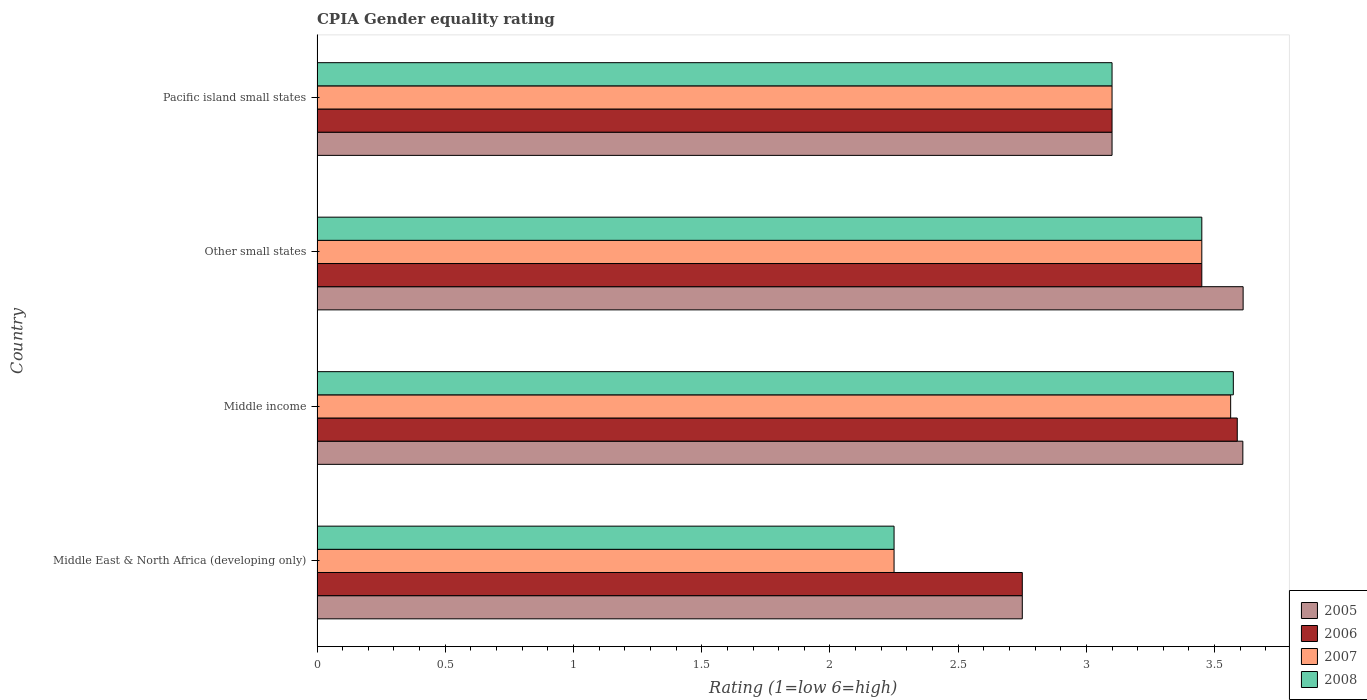How many different coloured bars are there?
Offer a terse response. 4. How many groups of bars are there?
Give a very brief answer. 4. What is the label of the 2nd group of bars from the top?
Ensure brevity in your answer.  Other small states. In how many cases, is the number of bars for a given country not equal to the number of legend labels?
Provide a succinct answer. 0. What is the CPIA rating in 2006 in Other small states?
Your answer should be very brief. 3.45. Across all countries, what is the maximum CPIA rating in 2006?
Make the answer very short. 3.59. Across all countries, what is the minimum CPIA rating in 2006?
Offer a very short reply. 2.75. In which country was the CPIA rating in 2006 maximum?
Provide a short and direct response. Middle income. In which country was the CPIA rating in 2007 minimum?
Make the answer very short. Middle East & North Africa (developing only). What is the total CPIA rating in 2005 in the graph?
Your response must be concise. 13.07. What is the difference between the CPIA rating in 2007 in Middle income and that in Pacific island small states?
Ensure brevity in your answer.  0.46. What is the difference between the CPIA rating in 2006 in Pacific island small states and the CPIA rating in 2005 in Other small states?
Offer a very short reply. -0.51. What is the average CPIA rating in 2008 per country?
Make the answer very short. 3.09. What is the difference between the CPIA rating in 2007 and CPIA rating in 2008 in Pacific island small states?
Your answer should be compact. 0. What is the ratio of the CPIA rating in 2006 in Middle East & North Africa (developing only) to that in Pacific island small states?
Your response must be concise. 0.89. What is the difference between the highest and the second highest CPIA rating in 2007?
Provide a succinct answer. 0.11. What is the difference between the highest and the lowest CPIA rating in 2005?
Your answer should be very brief. 0.86. In how many countries, is the CPIA rating in 2008 greater than the average CPIA rating in 2008 taken over all countries?
Ensure brevity in your answer.  3. What does the 3rd bar from the bottom in Other small states represents?
Make the answer very short. 2007. Is it the case that in every country, the sum of the CPIA rating in 2007 and CPIA rating in 2006 is greater than the CPIA rating in 2008?
Make the answer very short. Yes. Are all the bars in the graph horizontal?
Ensure brevity in your answer.  Yes. Does the graph contain any zero values?
Provide a succinct answer. No. Does the graph contain grids?
Your answer should be very brief. No. Where does the legend appear in the graph?
Make the answer very short. Bottom right. How are the legend labels stacked?
Make the answer very short. Vertical. What is the title of the graph?
Ensure brevity in your answer.  CPIA Gender equality rating. Does "1976" appear as one of the legend labels in the graph?
Ensure brevity in your answer.  No. What is the label or title of the X-axis?
Give a very brief answer. Rating (1=low 6=high). What is the label or title of the Y-axis?
Keep it short and to the point. Country. What is the Rating (1=low 6=high) in 2005 in Middle East & North Africa (developing only)?
Offer a very short reply. 2.75. What is the Rating (1=low 6=high) in 2006 in Middle East & North Africa (developing only)?
Provide a succinct answer. 2.75. What is the Rating (1=low 6=high) in 2007 in Middle East & North Africa (developing only)?
Offer a terse response. 2.25. What is the Rating (1=low 6=high) of 2008 in Middle East & North Africa (developing only)?
Make the answer very short. 2.25. What is the Rating (1=low 6=high) in 2005 in Middle income?
Provide a succinct answer. 3.61. What is the Rating (1=low 6=high) of 2006 in Middle income?
Offer a very short reply. 3.59. What is the Rating (1=low 6=high) of 2007 in Middle income?
Your answer should be very brief. 3.56. What is the Rating (1=low 6=high) of 2008 in Middle income?
Ensure brevity in your answer.  3.57. What is the Rating (1=low 6=high) in 2005 in Other small states?
Give a very brief answer. 3.61. What is the Rating (1=low 6=high) in 2006 in Other small states?
Ensure brevity in your answer.  3.45. What is the Rating (1=low 6=high) in 2007 in Other small states?
Provide a succinct answer. 3.45. What is the Rating (1=low 6=high) of 2008 in Other small states?
Give a very brief answer. 3.45. What is the Rating (1=low 6=high) in 2006 in Pacific island small states?
Offer a very short reply. 3.1. What is the Rating (1=low 6=high) of 2007 in Pacific island small states?
Make the answer very short. 3.1. What is the Rating (1=low 6=high) of 2008 in Pacific island small states?
Offer a very short reply. 3.1. Across all countries, what is the maximum Rating (1=low 6=high) in 2005?
Give a very brief answer. 3.61. Across all countries, what is the maximum Rating (1=low 6=high) in 2006?
Provide a succinct answer. 3.59. Across all countries, what is the maximum Rating (1=low 6=high) in 2007?
Offer a very short reply. 3.56. Across all countries, what is the maximum Rating (1=low 6=high) in 2008?
Your response must be concise. 3.57. Across all countries, what is the minimum Rating (1=low 6=high) of 2005?
Your answer should be compact. 2.75. Across all countries, what is the minimum Rating (1=low 6=high) of 2006?
Your answer should be compact. 2.75. Across all countries, what is the minimum Rating (1=low 6=high) in 2007?
Offer a terse response. 2.25. Across all countries, what is the minimum Rating (1=low 6=high) in 2008?
Make the answer very short. 2.25. What is the total Rating (1=low 6=high) of 2005 in the graph?
Offer a very short reply. 13.07. What is the total Rating (1=low 6=high) of 2006 in the graph?
Offer a very short reply. 12.89. What is the total Rating (1=low 6=high) in 2007 in the graph?
Your answer should be very brief. 12.36. What is the total Rating (1=low 6=high) in 2008 in the graph?
Your response must be concise. 12.37. What is the difference between the Rating (1=low 6=high) in 2005 in Middle East & North Africa (developing only) and that in Middle income?
Your answer should be compact. -0.86. What is the difference between the Rating (1=low 6=high) in 2006 in Middle East & North Africa (developing only) and that in Middle income?
Make the answer very short. -0.84. What is the difference between the Rating (1=low 6=high) of 2007 in Middle East & North Africa (developing only) and that in Middle income?
Provide a short and direct response. -1.31. What is the difference between the Rating (1=low 6=high) of 2008 in Middle East & North Africa (developing only) and that in Middle income?
Offer a terse response. -1.32. What is the difference between the Rating (1=low 6=high) in 2005 in Middle East & North Africa (developing only) and that in Other small states?
Provide a succinct answer. -0.86. What is the difference between the Rating (1=low 6=high) in 2006 in Middle East & North Africa (developing only) and that in Other small states?
Provide a succinct answer. -0.7. What is the difference between the Rating (1=low 6=high) in 2008 in Middle East & North Africa (developing only) and that in Other small states?
Offer a very short reply. -1.2. What is the difference between the Rating (1=low 6=high) in 2005 in Middle East & North Africa (developing only) and that in Pacific island small states?
Give a very brief answer. -0.35. What is the difference between the Rating (1=low 6=high) of 2006 in Middle East & North Africa (developing only) and that in Pacific island small states?
Make the answer very short. -0.35. What is the difference between the Rating (1=low 6=high) of 2007 in Middle East & North Africa (developing only) and that in Pacific island small states?
Make the answer very short. -0.85. What is the difference between the Rating (1=low 6=high) in 2008 in Middle East & North Africa (developing only) and that in Pacific island small states?
Your answer should be very brief. -0.85. What is the difference between the Rating (1=low 6=high) in 2005 in Middle income and that in Other small states?
Offer a very short reply. -0. What is the difference between the Rating (1=low 6=high) in 2006 in Middle income and that in Other small states?
Make the answer very short. 0.14. What is the difference between the Rating (1=low 6=high) in 2007 in Middle income and that in Other small states?
Your answer should be compact. 0.11. What is the difference between the Rating (1=low 6=high) of 2008 in Middle income and that in Other small states?
Offer a terse response. 0.12. What is the difference between the Rating (1=low 6=high) in 2005 in Middle income and that in Pacific island small states?
Offer a very short reply. 0.51. What is the difference between the Rating (1=low 6=high) of 2006 in Middle income and that in Pacific island small states?
Ensure brevity in your answer.  0.49. What is the difference between the Rating (1=low 6=high) of 2007 in Middle income and that in Pacific island small states?
Provide a short and direct response. 0.46. What is the difference between the Rating (1=low 6=high) of 2008 in Middle income and that in Pacific island small states?
Provide a succinct answer. 0.47. What is the difference between the Rating (1=low 6=high) in 2005 in Other small states and that in Pacific island small states?
Your answer should be very brief. 0.51. What is the difference between the Rating (1=low 6=high) of 2006 in Other small states and that in Pacific island small states?
Keep it short and to the point. 0.35. What is the difference between the Rating (1=low 6=high) of 2007 in Other small states and that in Pacific island small states?
Your answer should be compact. 0.35. What is the difference between the Rating (1=low 6=high) of 2008 in Other small states and that in Pacific island small states?
Make the answer very short. 0.35. What is the difference between the Rating (1=low 6=high) in 2005 in Middle East & North Africa (developing only) and the Rating (1=low 6=high) in 2006 in Middle income?
Keep it short and to the point. -0.84. What is the difference between the Rating (1=low 6=high) of 2005 in Middle East & North Africa (developing only) and the Rating (1=low 6=high) of 2007 in Middle income?
Provide a succinct answer. -0.81. What is the difference between the Rating (1=low 6=high) in 2005 in Middle East & North Africa (developing only) and the Rating (1=low 6=high) in 2008 in Middle income?
Offer a terse response. -0.82. What is the difference between the Rating (1=low 6=high) in 2006 in Middle East & North Africa (developing only) and the Rating (1=low 6=high) in 2007 in Middle income?
Give a very brief answer. -0.81. What is the difference between the Rating (1=low 6=high) in 2006 in Middle East & North Africa (developing only) and the Rating (1=low 6=high) in 2008 in Middle income?
Make the answer very short. -0.82. What is the difference between the Rating (1=low 6=high) of 2007 in Middle East & North Africa (developing only) and the Rating (1=low 6=high) of 2008 in Middle income?
Your response must be concise. -1.32. What is the difference between the Rating (1=low 6=high) of 2005 in Middle East & North Africa (developing only) and the Rating (1=low 6=high) of 2006 in Other small states?
Keep it short and to the point. -0.7. What is the difference between the Rating (1=low 6=high) of 2005 in Middle East & North Africa (developing only) and the Rating (1=low 6=high) of 2008 in Other small states?
Offer a very short reply. -0.7. What is the difference between the Rating (1=low 6=high) in 2006 in Middle East & North Africa (developing only) and the Rating (1=low 6=high) in 2007 in Other small states?
Your answer should be very brief. -0.7. What is the difference between the Rating (1=low 6=high) in 2006 in Middle East & North Africa (developing only) and the Rating (1=low 6=high) in 2008 in Other small states?
Your response must be concise. -0.7. What is the difference between the Rating (1=low 6=high) in 2005 in Middle East & North Africa (developing only) and the Rating (1=low 6=high) in 2006 in Pacific island small states?
Give a very brief answer. -0.35. What is the difference between the Rating (1=low 6=high) in 2005 in Middle East & North Africa (developing only) and the Rating (1=low 6=high) in 2007 in Pacific island small states?
Provide a short and direct response. -0.35. What is the difference between the Rating (1=low 6=high) of 2005 in Middle East & North Africa (developing only) and the Rating (1=low 6=high) of 2008 in Pacific island small states?
Ensure brevity in your answer.  -0.35. What is the difference between the Rating (1=low 6=high) of 2006 in Middle East & North Africa (developing only) and the Rating (1=low 6=high) of 2007 in Pacific island small states?
Offer a terse response. -0.35. What is the difference between the Rating (1=low 6=high) in 2006 in Middle East & North Africa (developing only) and the Rating (1=low 6=high) in 2008 in Pacific island small states?
Make the answer very short. -0.35. What is the difference between the Rating (1=low 6=high) of 2007 in Middle East & North Africa (developing only) and the Rating (1=low 6=high) of 2008 in Pacific island small states?
Keep it short and to the point. -0.85. What is the difference between the Rating (1=low 6=high) of 2005 in Middle income and the Rating (1=low 6=high) of 2006 in Other small states?
Give a very brief answer. 0.16. What is the difference between the Rating (1=low 6=high) of 2005 in Middle income and the Rating (1=low 6=high) of 2007 in Other small states?
Make the answer very short. 0.16. What is the difference between the Rating (1=low 6=high) in 2005 in Middle income and the Rating (1=low 6=high) in 2008 in Other small states?
Ensure brevity in your answer.  0.16. What is the difference between the Rating (1=low 6=high) in 2006 in Middle income and the Rating (1=low 6=high) in 2007 in Other small states?
Ensure brevity in your answer.  0.14. What is the difference between the Rating (1=low 6=high) in 2006 in Middle income and the Rating (1=low 6=high) in 2008 in Other small states?
Your response must be concise. 0.14. What is the difference between the Rating (1=low 6=high) of 2007 in Middle income and the Rating (1=low 6=high) of 2008 in Other small states?
Your answer should be compact. 0.11. What is the difference between the Rating (1=low 6=high) in 2005 in Middle income and the Rating (1=low 6=high) in 2006 in Pacific island small states?
Your response must be concise. 0.51. What is the difference between the Rating (1=low 6=high) in 2005 in Middle income and the Rating (1=low 6=high) in 2007 in Pacific island small states?
Offer a very short reply. 0.51. What is the difference between the Rating (1=low 6=high) of 2005 in Middle income and the Rating (1=low 6=high) of 2008 in Pacific island small states?
Keep it short and to the point. 0.51. What is the difference between the Rating (1=low 6=high) in 2006 in Middle income and the Rating (1=low 6=high) in 2007 in Pacific island small states?
Your answer should be very brief. 0.49. What is the difference between the Rating (1=low 6=high) of 2006 in Middle income and the Rating (1=low 6=high) of 2008 in Pacific island small states?
Your answer should be very brief. 0.49. What is the difference between the Rating (1=low 6=high) of 2007 in Middle income and the Rating (1=low 6=high) of 2008 in Pacific island small states?
Ensure brevity in your answer.  0.46. What is the difference between the Rating (1=low 6=high) of 2005 in Other small states and the Rating (1=low 6=high) of 2006 in Pacific island small states?
Make the answer very short. 0.51. What is the difference between the Rating (1=low 6=high) of 2005 in Other small states and the Rating (1=low 6=high) of 2007 in Pacific island small states?
Provide a succinct answer. 0.51. What is the difference between the Rating (1=low 6=high) in 2005 in Other small states and the Rating (1=low 6=high) in 2008 in Pacific island small states?
Keep it short and to the point. 0.51. What is the difference between the Rating (1=low 6=high) in 2007 in Other small states and the Rating (1=low 6=high) in 2008 in Pacific island small states?
Ensure brevity in your answer.  0.35. What is the average Rating (1=low 6=high) in 2005 per country?
Offer a very short reply. 3.27. What is the average Rating (1=low 6=high) of 2006 per country?
Keep it short and to the point. 3.22. What is the average Rating (1=low 6=high) of 2007 per country?
Make the answer very short. 3.09. What is the average Rating (1=low 6=high) in 2008 per country?
Offer a very short reply. 3.09. What is the difference between the Rating (1=low 6=high) in 2005 and Rating (1=low 6=high) in 2008 in Middle East & North Africa (developing only)?
Give a very brief answer. 0.5. What is the difference between the Rating (1=low 6=high) of 2005 and Rating (1=low 6=high) of 2006 in Middle income?
Offer a very short reply. 0.02. What is the difference between the Rating (1=low 6=high) in 2005 and Rating (1=low 6=high) in 2007 in Middle income?
Your answer should be very brief. 0.05. What is the difference between the Rating (1=low 6=high) in 2005 and Rating (1=low 6=high) in 2008 in Middle income?
Your answer should be very brief. 0.04. What is the difference between the Rating (1=low 6=high) of 2006 and Rating (1=low 6=high) of 2007 in Middle income?
Your response must be concise. 0.03. What is the difference between the Rating (1=low 6=high) of 2006 and Rating (1=low 6=high) of 2008 in Middle income?
Make the answer very short. 0.02. What is the difference between the Rating (1=low 6=high) of 2007 and Rating (1=low 6=high) of 2008 in Middle income?
Your response must be concise. -0.01. What is the difference between the Rating (1=low 6=high) of 2005 and Rating (1=low 6=high) of 2006 in Other small states?
Keep it short and to the point. 0.16. What is the difference between the Rating (1=low 6=high) in 2005 and Rating (1=low 6=high) in 2007 in Other small states?
Your answer should be compact. 0.16. What is the difference between the Rating (1=low 6=high) in 2005 and Rating (1=low 6=high) in 2008 in Other small states?
Provide a short and direct response. 0.16. What is the difference between the Rating (1=low 6=high) in 2007 and Rating (1=low 6=high) in 2008 in Other small states?
Offer a very short reply. 0. What is the difference between the Rating (1=low 6=high) in 2005 and Rating (1=low 6=high) in 2007 in Pacific island small states?
Provide a succinct answer. 0. What is the difference between the Rating (1=low 6=high) in 2005 and Rating (1=low 6=high) in 2008 in Pacific island small states?
Make the answer very short. 0. What is the ratio of the Rating (1=low 6=high) of 2005 in Middle East & North Africa (developing only) to that in Middle income?
Offer a very short reply. 0.76. What is the ratio of the Rating (1=low 6=high) of 2006 in Middle East & North Africa (developing only) to that in Middle income?
Provide a short and direct response. 0.77. What is the ratio of the Rating (1=low 6=high) in 2007 in Middle East & North Africa (developing only) to that in Middle income?
Give a very brief answer. 0.63. What is the ratio of the Rating (1=low 6=high) in 2008 in Middle East & North Africa (developing only) to that in Middle income?
Ensure brevity in your answer.  0.63. What is the ratio of the Rating (1=low 6=high) of 2005 in Middle East & North Africa (developing only) to that in Other small states?
Provide a succinct answer. 0.76. What is the ratio of the Rating (1=low 6=high) in 2006 in Middle East & North Africa (developing only) to that in Other small states?
Provide a succinct answer. 0.8. What is the ratio of the Rating (1=low 6=high) of 2007 in Middle East & North Africa (developing only) to that in Other small states?
Your response must be concise. 0.65. What is the ratio of the Rating (1=low 6=high) in 2008 in Middle East & North Africa (developing only) to that in Other small states?
Give a very brief answer. 0.65. What is the ratio of the Rating (1=low 6=high) of 2005 in Middle East & North Africa (developing only) to that in Pacific island small states?
Keep it short and to the point. 0.89. What is the ratio of the Rating (1=low 6=high) in 2006 in Middle East & North Africa (developing only) to that in Pacific island small states?
Keep it short and to the point. 0.89. What is the ratio of the Rating (1=low 6=high) of 2007 in Middle East & North Africa (developing only) to that in Pacific island small states?
Give a very brief answer. 0.73. What is the ratio of the Rating (1=low 6=high) of 2008 in Middle East & North Africa (developing only) to that in Pacific island small states?
Your response must be concise. 0.73. What is the ratio of the Rating (1=low 6=high) of 2006 in Middle income to that in Other small states?
Make the answer very short. 1.04. What is the ratio of the Rating (1=low 6=high) of 2007 in Middle income to that in Other small states?
Keep it short and to the point. 1.03. What is the ratio of the Rating (1=low 6=high) in 2008 in Middle income to that in Other small states?
Offer a very short reply. 1.04. What is the ratio of the Rating (1=low 6=high) of 2005 in Middle income to that in Pacific island small states?
Offer a terse response. 1.16. What is the ratio of the Rating (1=low 6=high) of 2006 in Middle income to that in Pacific island small states?
Offer a terse response. 1.16. What is the ratio of the Rating (1=low 6=high) of 2007 in Middle income to that in Pacific island small states?
Your answer should be compact. 1.15. What is the ratio of the Rating (1=low 6=high) of 2008 in Middle income to that in Pacific island small states?
Your response must be concise. 1.15. What is the ratio of the Rating (1=low 6=high) of 2005 in Other small states to that in Pacific island small states?
Give a very brief answer. 1.16. What is the ratio of the Rating (1=low 6=high) in 2006 in Other small states to that in Pacific island small states?
Provide a succinct answer. 1.11. What is the ratio of the Rating (1=low 6=high) in 2007 in Other small states to that in Pacific island small states?
Offer a very short reply. 1.11. What is the ratio of the Rating (1=low 6=high) in 2008 in Other small states to that in Pacific island small states?
Keep it short and to the point. 1.11. What is the difference between the highest and the second highest Rating (1=low 6=high) of 2005?
Keep it short and to the point. 0. What is the difference between the highest and the second highest Rating (1=low 6=high) in 2006?
Your response must be concise. 0.14. What is the difference between the highest and the second highest Rating (1=low 6=high) of 2007?
Provide a short and direct response. 0.11. What is the difference between the highest and the second highest Rating (1=low 6=high) of 2008?
Your answer should be very brief. 0.12. What is the difference between the highest and the lowest Rating (1=low 6=high) of 2005?
Make the answer very short. 0.86. What is the difference between the highest and the lowest Rating (1=low 6=high) in 2006?
Offer a very short reply. 0.84. What is the difference between the highest and the lowest Rating (1=low 6=high) in 2007?
Keep it short and to the point. 1.31. What is the difference between the highest and the lowest Rating (1=low 6=high) of 2008?
Make the answer very short. 1.32. 